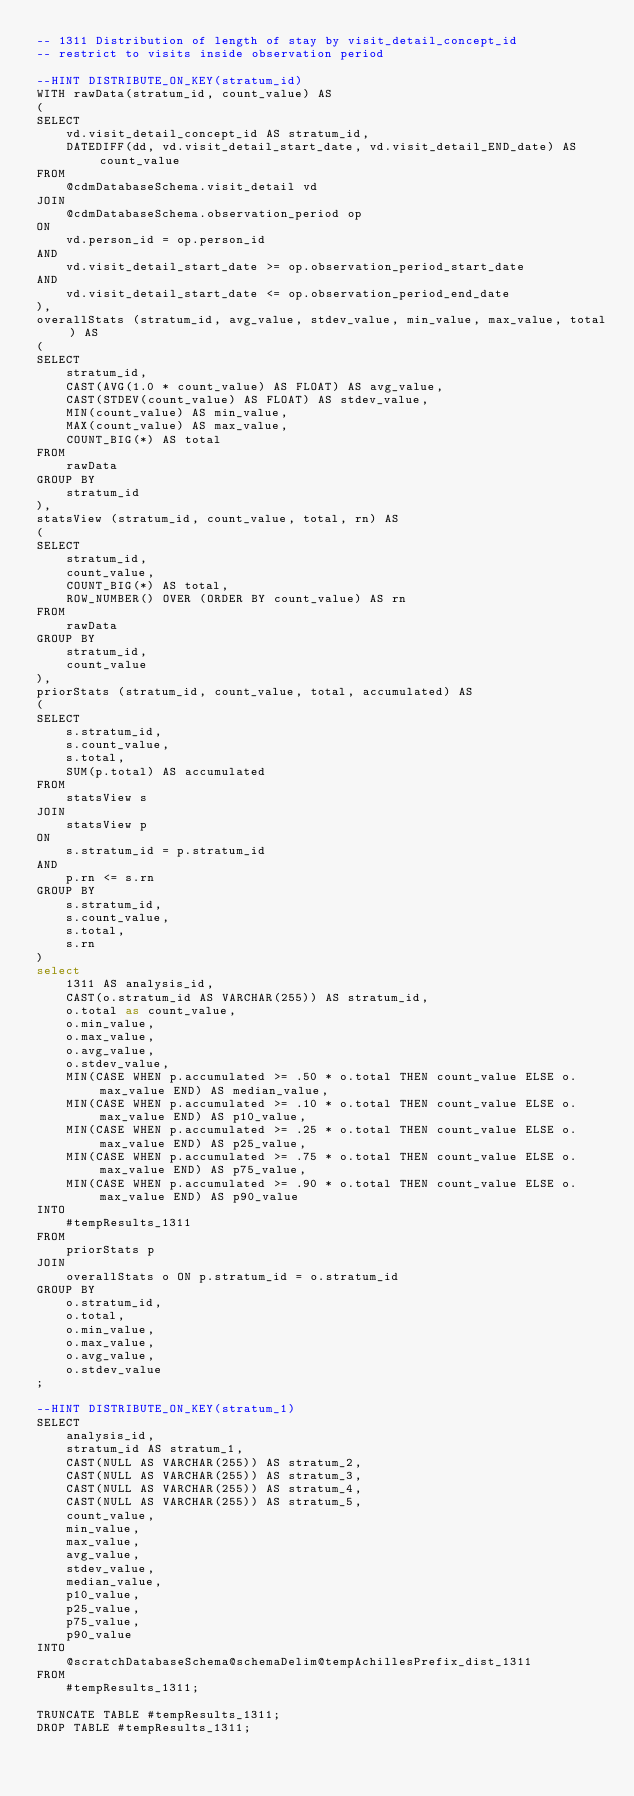Convert code to text. <code><loc_0><loc_0><loc_500><loc_500><_SQL_>-- 1311	Distribution of length of stay by visit_detail_concept_id
-- restrict to visits inside observation period

--HINT DISTRIBUTE_ON_KEY(stratum_id) 
WITH rawData(stratum_id, count_value) AS
(
SELECT 
	vd.visit_detail_concept_id AS stratum_id,
	DATEDIFF(dd, vd.visit_detail_start_date, vd.visit_detail_END_date) AS count_value
FROM 
	@cdmDatabaseSchema.visit_detail vd
JOIN 
	@cdmDatabaseSchema.observation_period op 
ON 
	vd.person_id = op.person_id
AND	
	vd.visit_detail_start_date >= op.observation_period_start_date  
AND 
	vd.visit_detail_start_date <= op.observation_period_end_date
),
overallStats (stratum_id, avg_value, stdev_value, min_value, max_value, total) AS
(
SELECT 
	stratum_id,
	CAST(AVG(1.0 * count_value) AS FLOAT) AS avg_value,
	CAST(STDEV(count_value) AS FLOAT) AS stdev_value,
	MIN(count_value) AS min_value,
	MAX(count_value) AS max_value,
	COUNT_BIG(*) AS total
FROM 
	rawData
GROUP BY 
	stratum_id
),
statsView (stratum_id, count_value, total, rn) AS
(
SELECT 
	stratum_id,
	count_value,
	COUNT_BIG(*) AS total,
	ROW_NUMBER() OVER (ORDER BY count_value) AS rn
FROM 
	rawData
GROUP BY 
	stratum_id,
	count_value
),
priorStats (stratum_id, count_value, total, accumulated) AS
(
SELECT 
	s.stratum_id,
	s.count_value,
	s.total,
	SUM(p.total) AS accumulated
FROM 
	statsView s
JOIN 
	statsView p 
ON 
	s.stratum_id = p.stratum_id
AND 
	p.rn <= s.rn
GROUP BY 
	s.stratum_id,
	s.count_value,
	s.total,
	s.rn
)
select 
	1311 AS analysis_id,
	CAST(o.stratum_id AS VARCHAR(255)) AS stratum_id,
	o.total as count_value,
	o.min_value,
	o.max_value,
	o.avg_value,
	o.stdev_value,
	MIN(CASE WHEN p.accumulated >= .50 * o.total THEN count_value ELSE o.max_value END) AS median_value,
	MIN(CASE WHEN p.accumulated >= .10 * o.total THEN count_value ELSE o.max_value END) AS p10_value,
	MIN(CASE WHEN p.accumulated >= .25 * o.total THEN count_value ELSE o.max_value END) AS p25_value,
	MIN(CASE WHEN p.accumulated >= .75 * o.total THEN count_value ELSE o.max_value END) AS p75_value,
	MIN(CASE WHEN p.accumulated >= .90 * o.total THEN count_value ELSE o.max_value END) AS p90_value
INTO 
	#tempResults_1311
FROM 
	priorStats p
JOIN 
	overallStats o ON p.stratum_id = o.stratum_id
GROUP BY 
	o.stratum_id, 
	o.total, 
	o.min_value, 
	o.max_value, 
	o.avg_value, 
	o.stdev_value
;

--HINT DISTRIBUTE_ON_KEY(stratum_1) 
SELECT 
	analysis_id,
	stratum_id AS stratum_1,
	CAST(NULL AS VARCHAR(255)) AS stratum_2,
	CAST(NULL AS VARCHAR(255)) AS stratum_3,
	CAST(NULL AS VARCHAR(255)) AS stratum_4,
	CAST(NULL AS VARCHAR(255)) AS stratum_5,
	count_value,
	min_value,
	max_value,
	avg_value,
	stdev_value,
	median_value,
	p10_value,
	p25_value,
	p75_value,
	p90_value
INTO 
	@scratchDatabaseSchema@schemaDelim@tempAchillesPrefix_dist_1311
FROM 
	#tempResults_1311;

TRUNCATE TABLE #tempResults_1311;
DROP TABLE #tempResults_1311;
</code> 